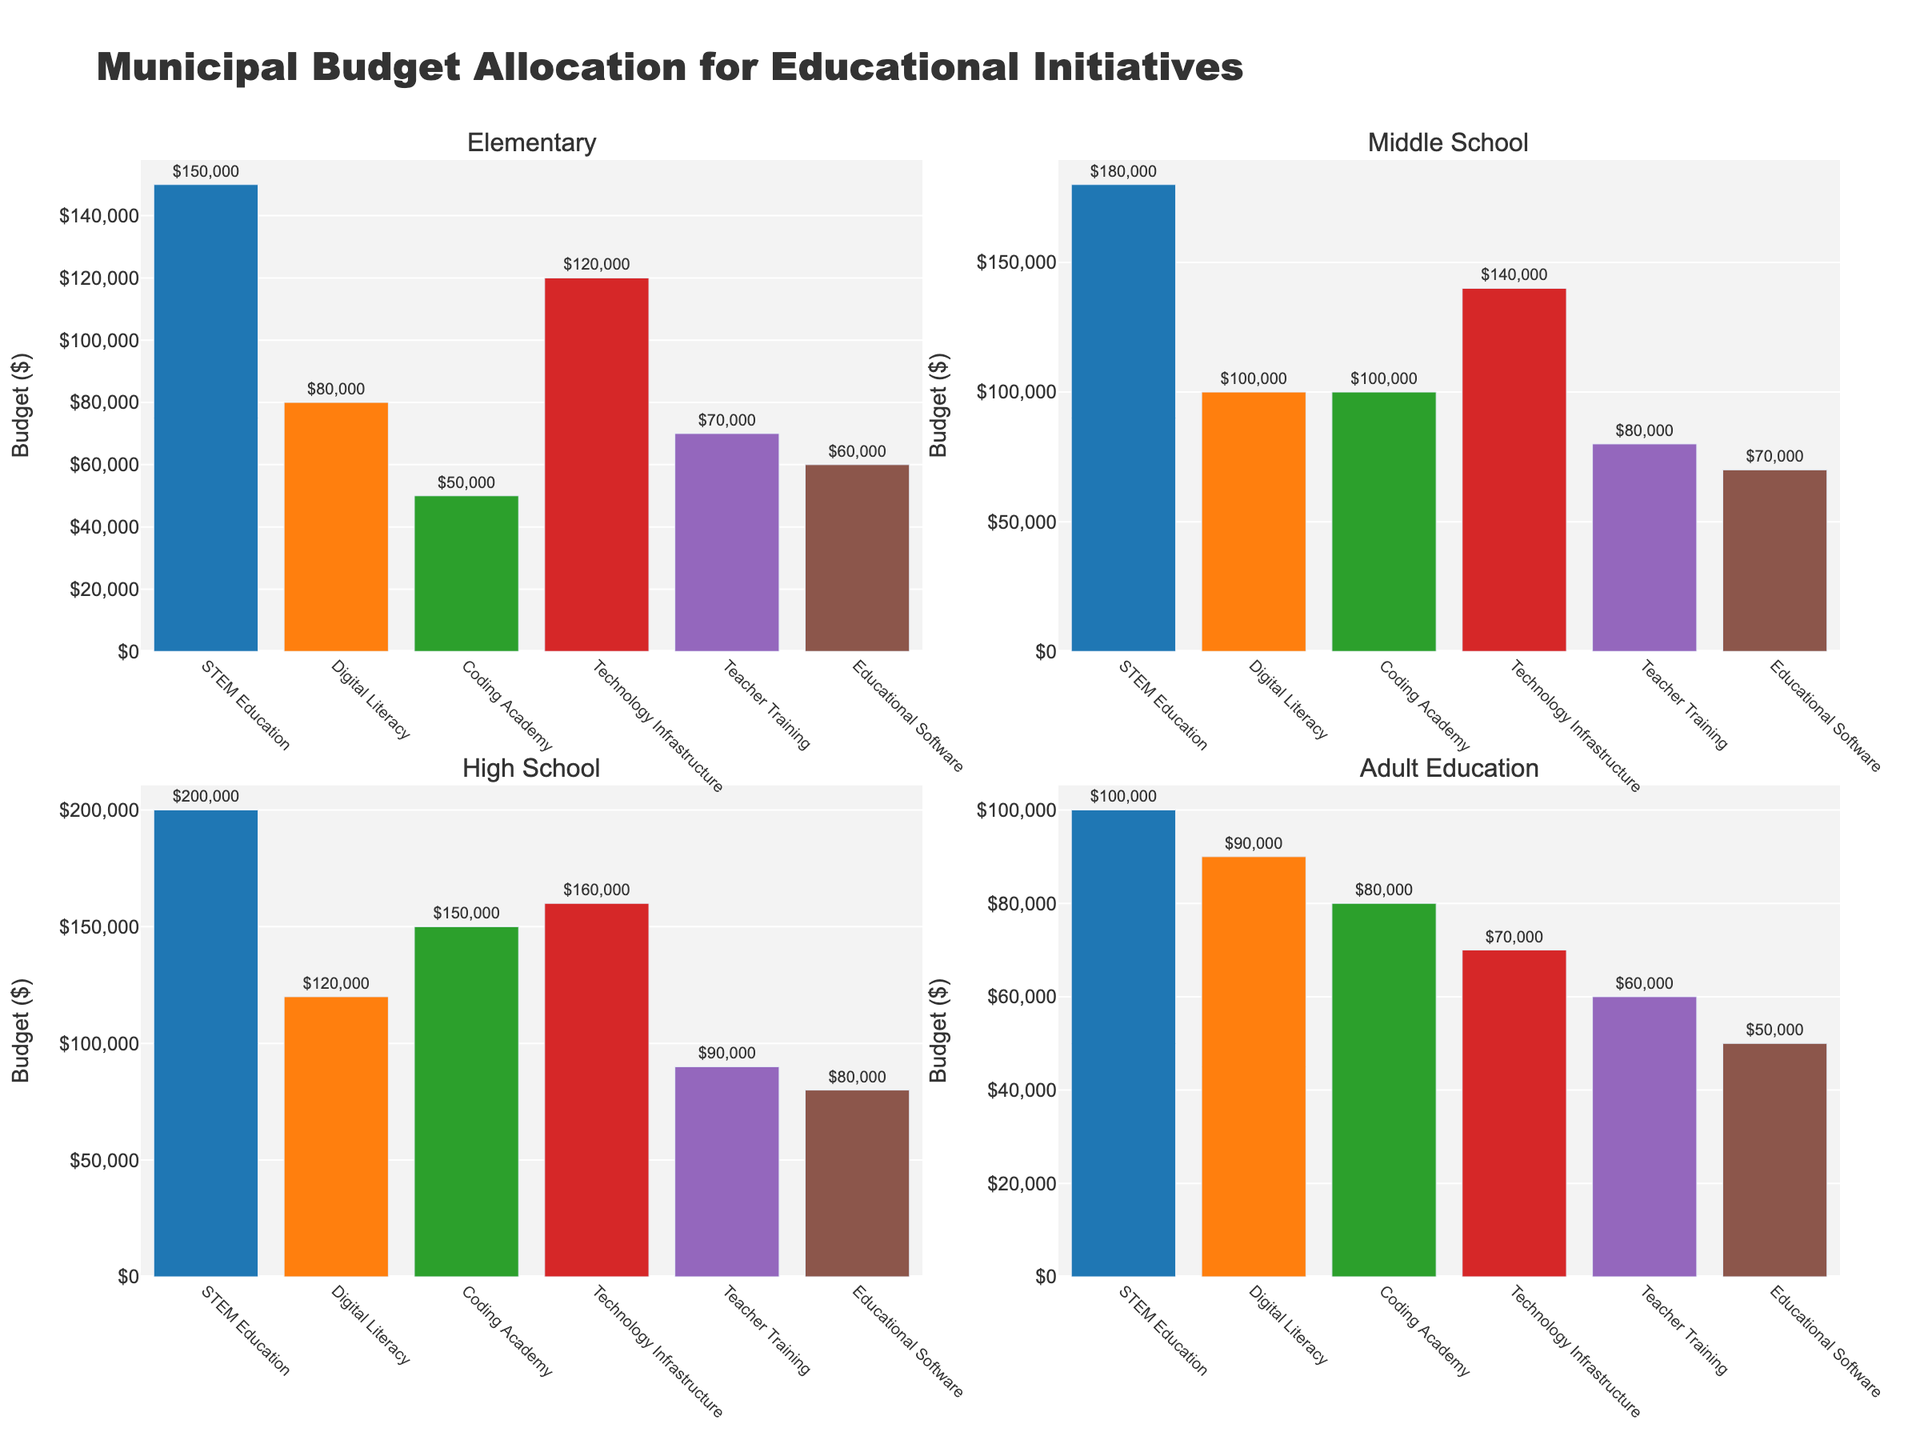What's the title of the figure? The title is located at the top of the figure in larger, bold text. It summarizes the data being shown in the figure.
Answer: Municipal Budget Allocation for Educational Initiatives Which department received the highest budget for Elementary education? Look at the sub-plot titled "Elementary" and identify the bar with the highest value.
Answer: STEM Education How much more budget did the High School STEM Education receive compared to Adult Education STEM Education? Find the values from the High School and Adult Education bars for STEM Education, then subtract the Adult Education value from the High School value: $200,000 - $100,000 = $100,000.
Answer: $100,000 Compare the budgets allocated to Technology Infrastructure in Middle School and High School. Which is greater and by how much? Look at the sub-plots titled "Middle School" and "High School," find the bars for Technology Infrastructure, and subtract the Middle School value from the High School value: $160,000 - $140,000 = $20,000.
Answer: High School by $20,000 What's the sum of the budgets for Coding Academy across all education levels? Add the values from the Coding Academy bars in all sub-plots: $50,000 + $100,000 + $150,000 + $80,000 = $380,000.
Answer: $380,000 Which department has the lowest budget allocation in Adult Education, and what is the amount? Look at the sub-plot titled "Adult Education" and identify the department with the shortest bar.
Answer: Educational Software with $50,000 How does the Elementary budget for Teacher Training compare to its Middle School budget? Compare the heights of the Teacher Training bars in the "Elementary" and "Middle School" sub-plots.
Answer: Less than Middle School Which sub-plot shows the least variation in budget allocations? Identify the subplot where the bars are most similar in height.
Answer: Adult Education What's the total budget allocated to Digital Literacy for Elementary and Middle School combined? Sum the values for Digital Literacy in the "Elementary" and "Middle School" sub-plots: $80,000 + $100,000 = $180,000.
Answer: $180,000 If the funding for Technology Infrastructure in High School increased by 25%, what would the new budget be? Calculate 25% of the current budget for Technology Infrastructure in High School and add it to the original value: 0.25 * $160,000 = $40,000, then $160,000 + $40,000 = $200,000.
Answer: $200,000 